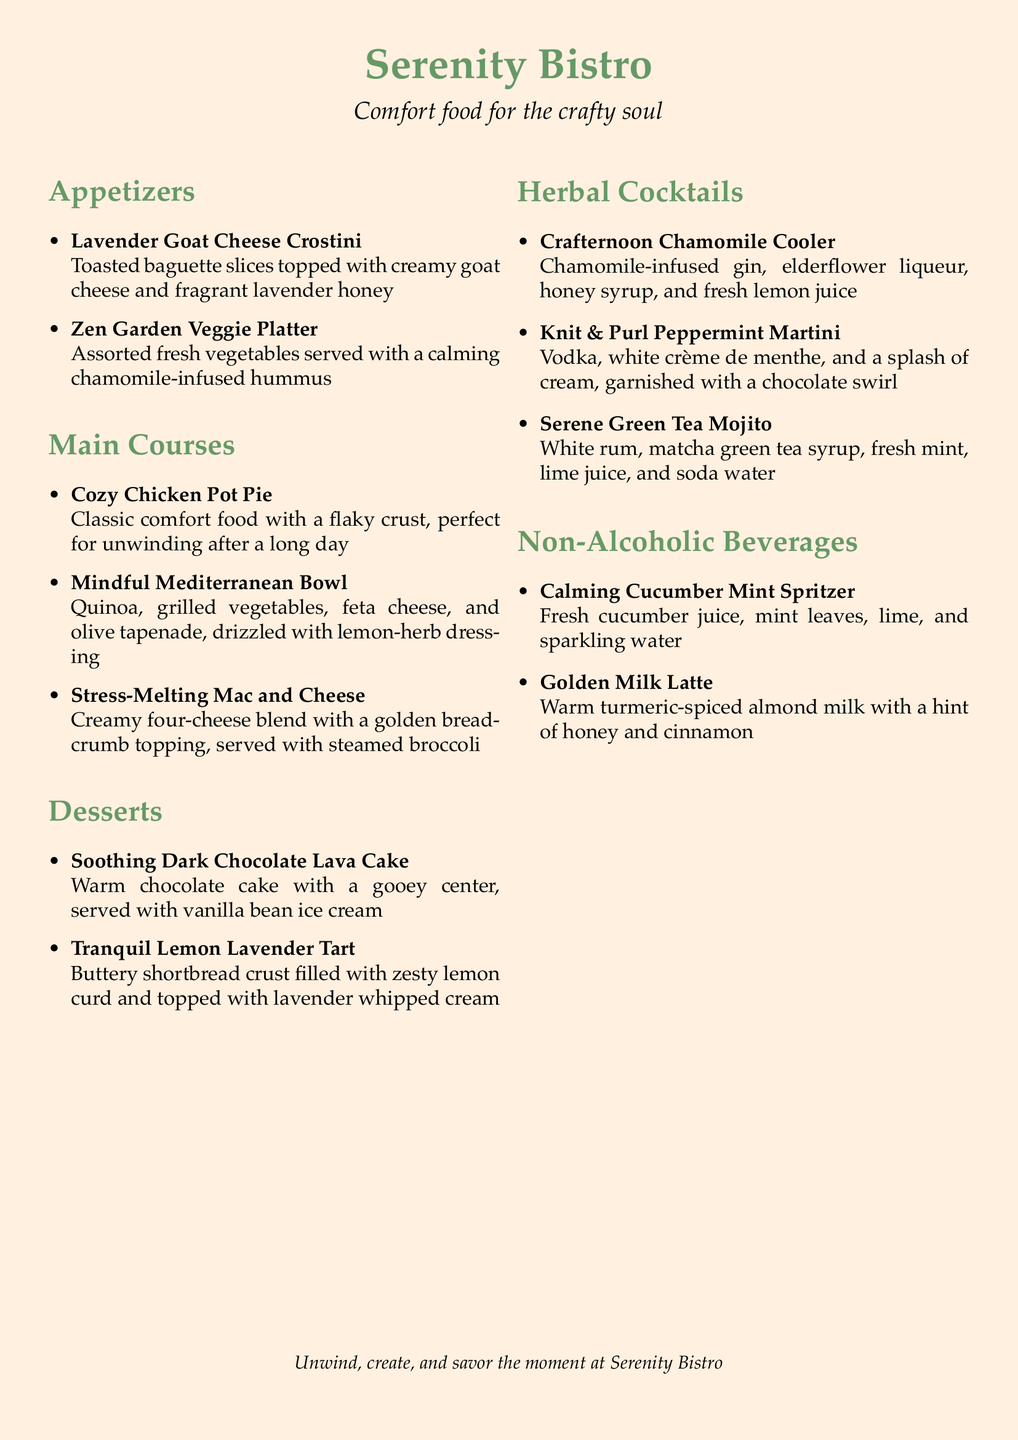What is the name of the bistro? The name of the bistro is prominently displayed at the top of the menu document.
Answer: Serenity Bistro What type of food does Serenity Bistro focus on? The bistro specializes in comfort food, as indicated in the tagline.
Answer: Comfort food How many appetizers are listed on the menu? The menu shows two appetizers under the Appetizers section.
Answer: 2 What is the main ingredient in the Cozy Chicken Pot Pie? The name describes the dish, which is a classic comfort food featuring chicken.
Answer: Chicken Which dessert features lavender? The dessert section contains a dessert with lavender in its title.
Answer: Tranquil Lemon Lavender Tart What is included in the Crafternoon Chamomile Cooler? The cocktail name provides its components, which include chamomile-infused gin and other ingredients.
Answer: Chamomile-infused gin Which non-alcoholic beverage contains turmeric? The name of the latte clearly indicates its primary ingredient related to turmeric.
Answer: Golden Milk Latte What type of culinary theme is presented in the main course dishes? The main courses embrace a specific theme that aims at relaxation and comfort.
Answer: Relaxation and comfort How is the Stress-Melting Mac and Cheese described? The description emphasizes its creamy texture and comforting qualities.
Answer: Creamy four-cheese blend 